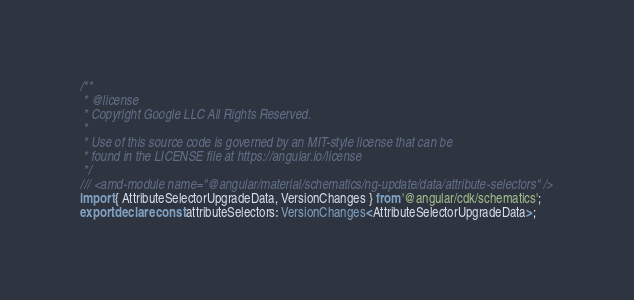Convert code to text. <code><loc_0><loc_0><loc_500><loc_500><_TypeScript_>/**
 * @license
 * Copyright Google LLC All Rights Reserved.
 *
 * Use of this source code is governed by an MIT-style license that can be
 * found in the LICENSE file at https://angular.io/license
 */
/// <amd-module name="@angular/material/schematics/ng-update/data/attribute-selectors" />
import { AttributeSelectorUpgradeData, VersionChanges } from '@angular/cdk/schematics';
export declare const attributeSelectors: VersionChanges<AttributeSelectorUpgradeData>;
</code> 